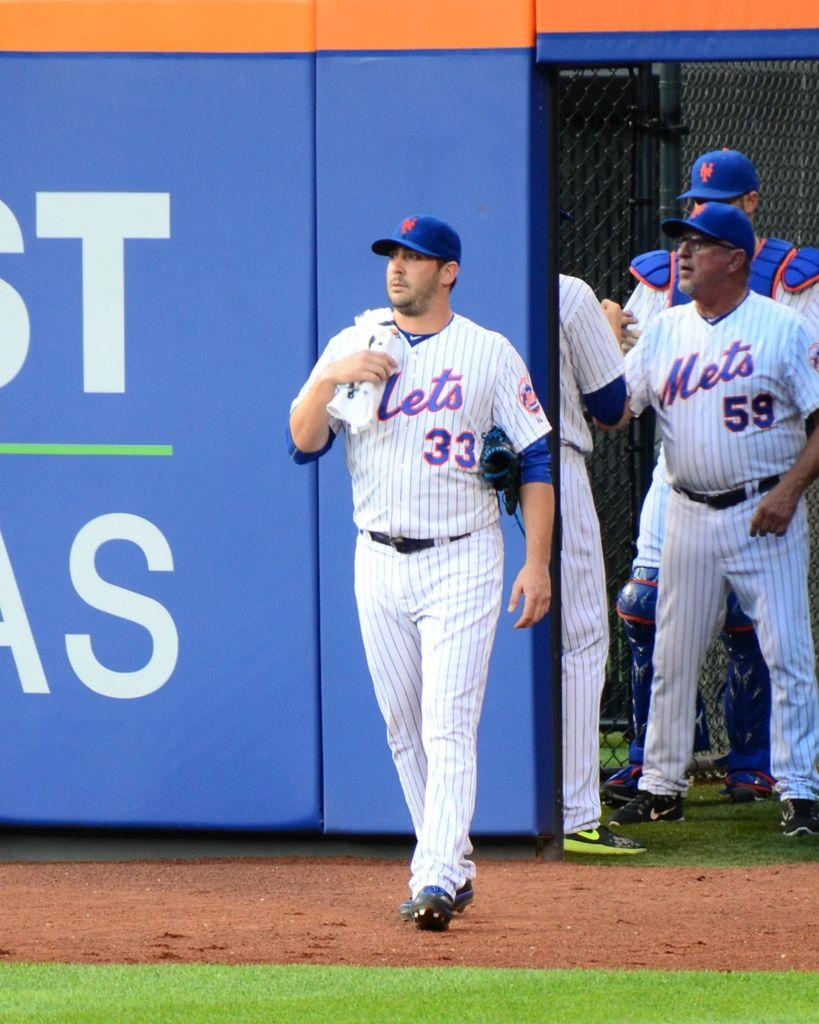<image>
Summarize the visual content of the image. Baseball player on the field wearing jersey number 33. 